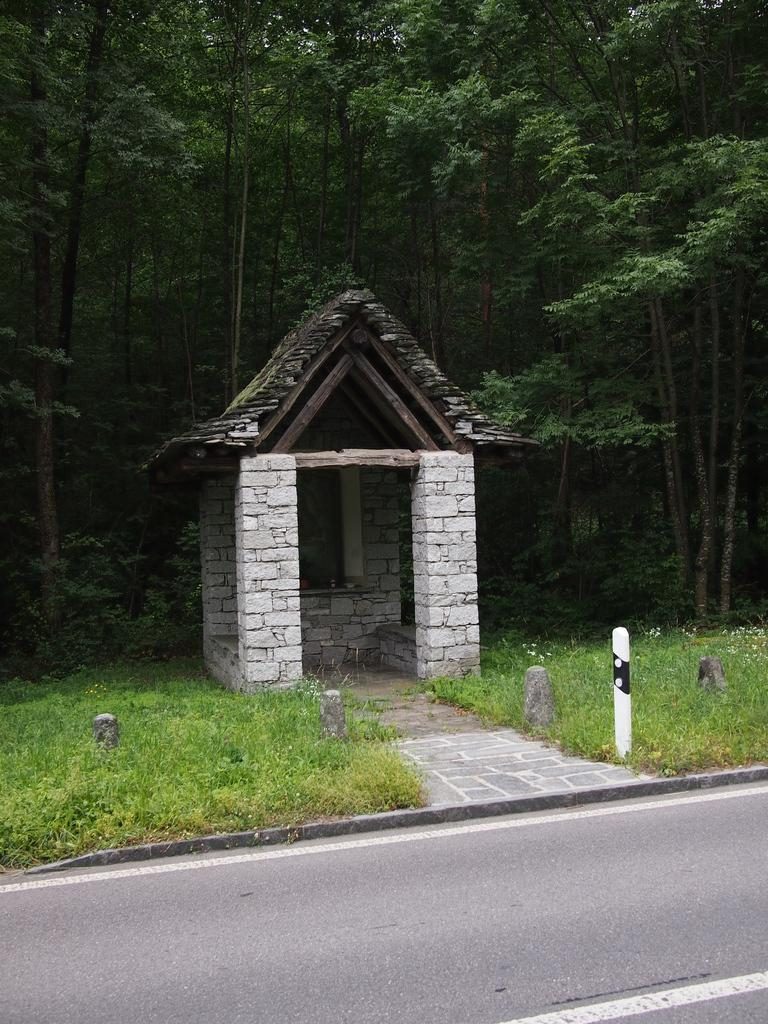What structure is located in the middle of the image? There is a shelter in the middle of the image. What type of ground is visible at the bottom of the image? There is grass at the bottom of the image. What can be seen in the background of the image? There are trees visible in the background of the image. What type of watch is hanging from the tree in the image? There is no watch present in the image; it only features a shelter, grass, and trees. 